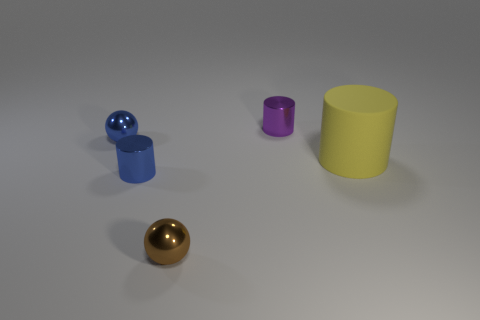Are there any other things that are the same size as the yellow matte thing?
Offer a terse response. No. The brown thing that is the same size as the purple metallic thing is what shape?
Your answer should be compact. Sphere. Are there any other objects of the same shape as the yellow rubber object?
Offer a very short reply. Yes. Are there any purple metallic objects that are to the right of the sphere on the right side of the small metal cylinder on the left side of the brown metal thing?
Your answer should be very brief. Yes. Is the number of brown metallic balls that are in front of the brown thing greater than the number of cylinders that are to the left of the rubber thing?
Give a very brief answer. No. What material is the brown thing that is the same size as the purple shiny thing?
Offer a terse response. Metal. How many big things are purple metal objects or blue metal cylinders?
Your response must be concise. 0. Do the big yellow thing and the tiny brown metallic thing have the same shape?
Your response must be concise. No. What number of shiny things are both right of the blue metal cylinder and in front of the yellow thing?
Offer a terse response. 1. Is there any other thing of the same color as the rubber thing?
Your answer should be very brief. No. 